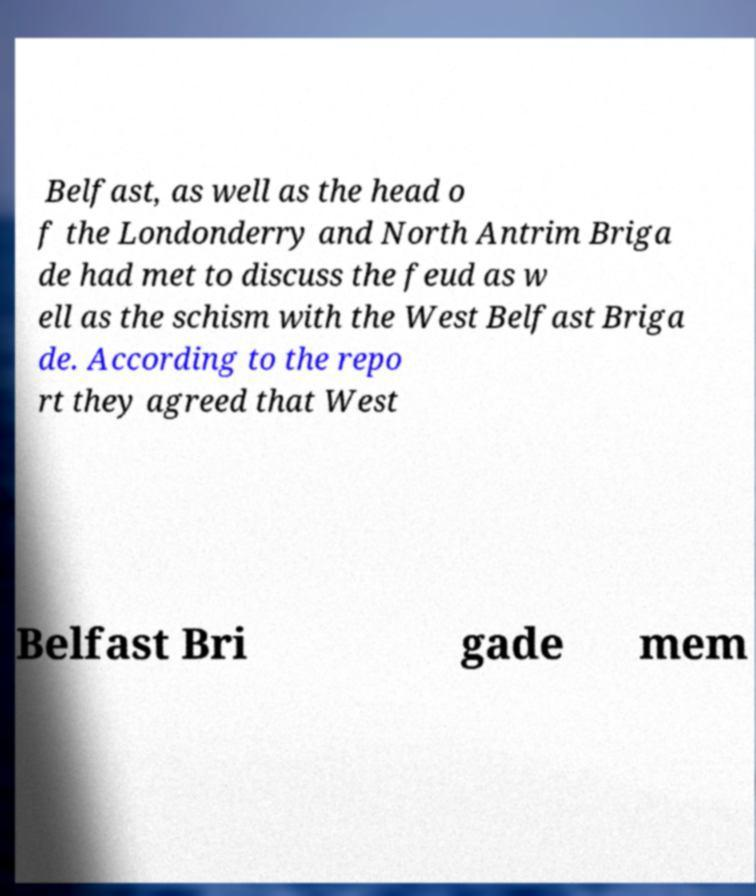Please read and relay the text visible in this image. What does it say? Belfast, as well as the head o f the Londonderry and North Antrim Briga de had met to discuss the feud as w ell as the schism with the West Belfast Briga de. According to the repo rt they agreed that West Belfast Bri gade mem 